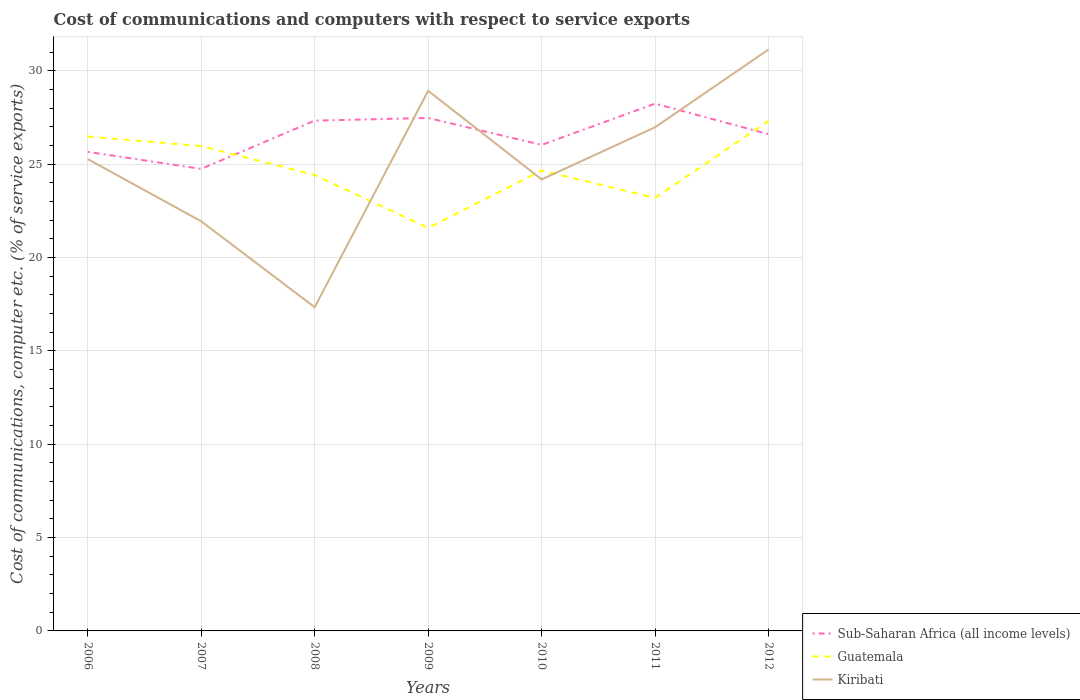Is the number of lines equal to the number of legend labels?
Ensure brevity in your answer.  Yes. Across all years, what is the maximum cost of communications and computers in Guatemala?
Make the answer very short. 21.59. In which year was the cost of communications and computers in Sub-Saharan Africa (all income levels) maximum?
Provide a short and direct response. 2007. What is the total cost of communications and computers in Kiribati in the graph?
Ensure brevity in your answer.  3.33. What is the difference between the highest and the second highest cost of communications and computers in Sub-Saharan Africa (all income levels)?
Offer a terse response. 3.49. How many lines are there?
Give a very brief answer. 3. What is the difference between two consecutive major ticks on the Y-axis?
Your answer should be very brief. 5. Are the values on the major ticks of Y-axis written in scientific E-notation?
Offer a terse response. No. Does the graph contain any zero values?
Your answer should be compact. No. Does the graph contain grids?
Your answer should be compact. Yes. What is the title of the graph?
Offer a terse response. Cost of communications and computers with respect to service exports. What is the label or title of the X-axis?
Offer a terse response. Years. What is the label or title of the Y-axis?
Your answer should be very brief. Cost of communications, computer etc. (% of service exports). What is the Cost of communications, computer etc. (% of service exports) of Sub-Saharan Africa (all income levels) in 2006?
Offer a very short reply. 25.66. What is the Cost of communications, computer etc. (% of service exports) of Guatemala in 2006?
Offer a very short reply. 26.49. What is the Cost of communications, computer etc. (% of service exports) of Kiribati in 2006?
Your response must be concise. 25.28. What is the Cost of communications, computer etc. (% of service exports) in Sub-Saharan Africa (all income levels) in 2007?
Your answer should be compact. 24.75. What is the Cost of communications, computer etc. (% of service exports) of Guatemala in 2007?
Ensure brevity in your answer.  25.98. What is the Cost of communications, computer etc. (% of service exports) of Kiribati in 2007?
Offer a terse response. 21.94. What is the Cost of communications, computer etc. (% of service exports) of Sub-Saharan Africa (all income levels) in 2008?
Provide a short and direct response. 27.34. What is the Cost of communications, computer etc. (% of service exports) of Guatemala in 2008?
Provide a succinct answer. 24.42. What is the Cost of communications, computer etc. (% of service exports) in Kiribati in 2008?
Provide a short and direct response. 17.34. What is the Cost of communications, computer etc. (% of service exports) in Sub-Saharan Africa (all income levels) in 2009?
Your response must be concise. 27.48. What is the Cost of communications, computer etc. (% of service exports) of Guatemala in 2009?
Your response must be concise. 21.59. What is the Cost of communications, computer etc. (% of service exports) of Kiribati in 2009?
Your response must be concise. 28.94. What is the Cost of communications, computer etc. (% of service exports) in Sub-Saharan Africa (all income levels) in 2010?
Provide a short and direct response. 26.04. What is the Cost of communications, computer etc. (% of service exports) in Guatemala in 2010?
Offer a very short reply. 24.66. What is the Cost of communications, computer etc. (% of service exports) in Kiribati in 2010?
Keep it short and to the point. 24.19. What is the Cost of communications, computer etc. (% of service exports) of Sub-Saharan Africa (all income levels) in 2011?
Offer a very short reply. 28.25. What is the Cost of communications, computer etc. (% of service exports) of Guatemala in 2011?
Keep it short and to the point. 23.2. What is the Cost of communications, computer etc. (% of service exports) of Kiribati in 2011?
Provide a succinct answer. 26.98. What is the Cost of communications, computer etc. (% of service exports) in Sub-Saharan Africa (all income levels) in 2012?
Make the answer very short. 26.61. What is the Cost of communications, computer etc. (% of service exports) of Guatemala in 2012?
Make the answer very short. 27.33. What is the Cost of communications, computer etc. (% of service exports) of Kiribati in 2012?
Your response must be concise. 31.15. Across all years, what is the maximum Cost of communications, computer etc. (% of service exports) of Sub-Saharan Africa (all income levels)?
Offer a terse response. 28.25. Across all years, what is the maximum Cost of communications, computer etc. (% of service exports) of Guatemala?
Offer a very short reply. 27.33. Across all years, what is the maximum Cost of communications, computer etc. (% of service exports) of Kiribati?
Your response must be concise. 31.15. Across all years, what is the minimum Cost of communications, computer etc. (% of service exports) in Sub-Saharan Africa (all income levels)?
Keep it short and to the point. 24.75. Across all years, what is the minimum Cost of communications, computer etc. (% of service exports) of Guatemala?
Your response must be concise. 21.59. Across all years, what is the minimum Cost of communications, computer etc. (% of service exports) in Kiribati?
Keep it short and to the point. 17.34. What is the total Cost of communications, computer etc. (% of service exports) in Sub-Saharan Africa (all income levels) in the graph?
Offer a very short reply. 186.14. What is the total Cost of communications, computer etc. (% of service exports) of Guatemala in the graph?
Provide a short and direct response. 173.67. What is the total Cost of communications, computer etc. (% of service exports) of Kiribati in the graph?
Make the answer very short. 175.83. What is the difference between the Cost of communications, computer etc. (% of service exports) in Sub-Saharan Africa (all income levels) in 2006 and that in 2007?
Your response must be concise. 0.91. What is the difference between the Cost of communications, computer etc. (% of service exports) of Guatemala in 2006 and that in 2007?
Your answer should be compact. 0.51. What is the difference between the Cost of communications, computer etc. (% of service exports) of Kiribati in 2006 and that in 2007?
Ensure brevity in your answer.  3.33. What is the difference between the Cost of communications, computer etc. (% of service exports) in Sub-Saharan Africa (all income levels) in 2006 and that in 2008?
Provide a succinct answer. -1.67. What is the difference between the Cost of communications, computer etc. (% of service exports) in Guatemala in 2006 and that in 2008?
Your response must be concise. 2.06. What is the difference between the Cost of communications, computer etc. (% of service exports) in Kiribati in 2006 and that in 2008?
Keep it short and to the point. 7.94. What is the difference between the Cost of communications, computer etc. (% of service exports) of Sub-Saharan Africa (all income levels) in 2006 and that in 2009?
Make the answer very short. -1.82. What is the difference between the Cost of communications, computer etc. (% of service exports) of Guatemala in 2006 and that in 2009?
Offer a terse response. 4.89. What is the difference between the Cost of communications, computer etc. (% of service exports) in Kiribati in 2006 and that in 2009?
Offer a terse response. -3.66. What is the difference between the Cost of communications, computer etc. (% of service exports) in Sub-Saharan Africa (all income levels) in 2006 and that in 2010?
Keep it short and to the point. -0.37. What is the difference between the Cost of communications, computer etc. (% of service exports) in Guatemala in 2006 and that in 2010?
Offer a very short reply. 1.82. What is the difference between the Cost of communications, computer etc. (% of service exports) of Kiribati in 2006 and that in 2010?
Your answer should be compact. 1.09. What is the difference between the Cost of communications, computer etc. (% of service exports) in Sub-Saharan Africa (all income levels) in 2006 and that in 2011?
Make the answer very short. -2.58. What is the difference between the Cost of communications, computer etc. (% of service exports) in Guatemala in 2006 and that in 2011?
Ensure brevity in your answer.  3.29. What is the difference between the Cost of communications, computer etc. (% of service exports) of Kiribati in 2006 and that in 2011?
Your answer should be compact. -1.71. What is the difference between the Cost of communications, computer etc. (% of service exports) in Sub-Saharan Africa (all income levels) in 2006 and that in 2012?
Your response must be concise. -0.95. What is the difference between the Cost of communications, computer etc. (% of service exports) of Guatemala in 2006 and that in 2012?
Ensure brevity in your answer.  -0.84. What is the difference between the Cost of communications, computer etc. (% of service exports) of Kiribati in 2006 and that in 2012?
Make the answer very short. -5.87. What is the difference between the Cost of communications, computer etc. (% of service exports) in Sub-Saharan Africa (all income levels) in 2007 and that in 2008?
Make the answer very short. -2.58. What is the difference between the Cost of communications, computer etc. (% of service exports) of Guatemala in 2007 and that in 2008?
Make the answer very short. 1.55. What is the difference between the Cost of communications, computer etc. (% of service exports) in Kiribati in 2007 and that in 2008?
Provide a short and direct response. 4.6. What is the difference between the Cost of communications, computer etc. (% of service exports) in Sub-Saharan Africa (all income levels) in 2007 and that in 2009?
Offer a terse response. -2.73. What is the difference between the Cost of communications, computer etc. (% of service exports) of Guatemala in 2007 and that in 2009?
Ensure brevity in your answer.  4.38. What is the difference between the Cost of communications, computer etc. (% of service exports) in Kiribati in 2007 and that in 2009?
Provide a short and direct response. -6.99. What is the difference between the Cost of communications, computer etc. (% of service exports) of Sub-Saharan Africa (all income levels) in 2007 and that in 2010?
Your answer should be compact. -1.28. What is the difference between the Cost of communications, computer etc. (% of service exports) of Guatemala in 2007 and that in 2010?
Your answer should be compact. 1.31. What is the difference between the Cost of communications, computer etc. (% of service exports) of Kiribati in 2007 and that in 2010?
Ensure brevity in your answer.  -2.25. What is the difference between the Cost of communications, computer etc. (% of service exports) of Sub-Saharan Africa (all income levels) in 2007 and that in 2011?
Ensure brevity in your answer.  -3.49. What is the difference between the Cost of communications, computer etc. (% of service exports) in Guatemala in 2007 and that in 2011?
Provide a succinct answer. 2.78. What is the difference between the Cost of communications, computer etc. (% of service exports) in Kiribati in 2007 and that in 2011?
Give a very brief answer. -5.04. What is the difference between the Cost of communications, computer etc. (% of service exports) of Sub-Saharan Africa (all income levels) in 2007 and that in 2012?
Offer a very short reply. -1.86. What is the difference between the Cost of communications, computer etc. (% of service exports) of Guatemala in 2007 and that in 2012?
Your answer should be compact. -1.35. What is the difference between the Cost of communications, computer etc. (% of service exports) of Kiribati in 2007 and that in 2012?
Make the answer very short. -9.21. What is the difference between the Cost of communications, computer etc. (% of service exports) of Sub-Saharan Africa (all income levels) in 2008 and that in 2009?
Keep it short and to the point. -0.14. What is the difference between the Cost of communications, computer etc. (% of service exports) in Guatemala in 2008 and that in 2009?
Your response must be concise. 2.83. What is the difference between the Cost of communications, computer etc. (% of service exports) of Kiribati in 2008 and that in 2009?
Provide a succinct answer. -11.59. What is the difference between the Cost of communications, computer etc. (% of service exports) of Sub-Saharan Africa (all income levels) in 2008 and that in 2010?
Make the answer very short. 1.3. What is the difference between the Cost of communications, computer etc. (% of service exports) of Guatemala in 2008 and that in 2010?
Provide a succinct answer. -0.24. What is the difference between the Cost of communications, computer etc. (% of service exports) of Kiribati in 2008 and that in 2010?
Ensure brevity in your answer.  -6.85. What is the difference between the Cost of communications, computer etc. (% of service exports) of Sub-Saharan Africa (all income levels) in 2008 and that in 2011?
Ensure brevity in your answer.  -0.91. What is the difference between the Cost of communications, computer etc. (% of service exports) in Guatemala in 2008 and that in 2011?
Your answer should be very brief. 1.22. What is the difference between the Cost of communications, computer etc. (% of service exports) in Kiribati in 2008 and that in 2011?
Offer a very short reply. -9.64. What is the difference between the Cost of communications, computer etc. (% of service exports) in Sub-Saharan Africa (all income levels) in 2008 and that in 2012?
Your answer should be compact. 0.73. What is the difference between the Cost of communications, computer etc. (% of service exports) in Guatemala in 2008 and that in 2012?
Ensure brevity in your answer.  -2.91. What is the difference between the Cost of communications, computer etc. (% of service exports) of Kiribati in 2008 and that in 2012?
Your response must be concise. -13.81. What is the difference between the Cost of communications, computer etc. (% of service exports) in Sub-Saharan Africa (all income levels) in 2009 and that in 2010?
Give a very brief answer. 1.44. What is the difference between the Cost of communications, computer etc. (% of service exports) in Guatemala in 2009 and that in 2010?
Keep it short and to the point. -3.07. What is the difference between the Cost of communications, computer etc. (% of service exports) of Kiribati in 2009 and that in 2010?
Ensure brevity in your answer.  4.75. What is the difference between the Cost of communications, computer etc. (% of service exports) in Sub-Saharan Africa (all income levels) in 2009 and that in 2011?
Give a very brief answer. -0.77. What is the difference between the Cost of communications, computer etc. (% of service exports) in Guatemala in 2009 and that in 2011?
Offer a very short reply. -1.61. What is the difference between the Cost of communications, computer etc. (% of service exports) of Kiribati in 2009 and that in 2011?
Offer a very short reply. 1.95. What is the difference between the Cost of communications, computer etc. (% of service exports) of Sub-Saharan Africa (all income levels) in 2009 and that in 2012?
Make the answer very short. 0.87. What is the difference between the Cost of communications, computer etc. (% of service exports) of Guatemala in 2009 and that in 2012?
Ensure brevity in your answer.  -5.74. What is the difference between the Cost of communications, computer etc. (% of service exports) in Kiribati in 2009 and that in 2012?
Your answer should be compact. -2.21. What is the difference between the Cost of communications, computer etc. (% of service exports) in Sub-Saharan Africa (all income levels) in 2010 and that in 2011?
Provide a succinct answer. -2.21. What is the difference between the Cost of communications, computer etc. (% of service exports) in Guatemala in 2010 and that in 2011?
Your response must be concise. 1.47. What is the difference between the Cost of communications, computer etc. (% of service exports) of Kiribati in 2010 and that in 2011?
Offer a terse response. -2.8. What is the difference between the Cost of communications, computer etc. (% of service exports) in Sub-Saharan Africa (all income levels) in 2010 and that in 2012?
Provide a short and direct response. -0.58. What is the difference between the Cost of communications, computer etc. (% of service exports) in Guatemala in 2010 and that in 2012?
Your answer should be compact. -2.67. What is the difference between the Cost of communications, computer etc. (% of service exports) in Kiribati in 2010 and that in 2012?
Your response must be concise. -6.96. What is the difference between the Cost of communications, computer etc. (% of service exports) of Sub-Saharan Africa (all income levels) in 2011 and that in 2012?
Provide a succinct answer. 1.63. What is the difference between the Cost of communications, computer etc. (% of service exports) of Guatemala in 2011 and that in 2012?
Provide a short and direct response. -4.13. What is the difference between the Cost of communications, computer etc. (% of service exports) in Kiribati in 2011 and that in 2012?
Ensure brevity in your answer.  -4.17. What is the difference between the Cost of communications, computer etc. (% of service exports) of Sub-Saharan Africa (all income levels) in 2006 and the Cost of communications, computer etc. (% of service exports) of Guatemala in 2007?
Provide a short and direct response. -0.31. What is the difference between the Cost of communications, computer etc. (% of service exports) of Sub-Saharan Africa (all income levels) in 2006 and the Cost of communications, computer etc. (% of service exports) of Kiribati in 2007?
Your answer should be compact. 3.72. What is the difference between the Cost of communications, computer etc. (% of service exports) in Guatemala in 2006 and the Cost of communications, computer etc. (% of service exports) in Kiribati in 2007?
Make the answer very short. 4.54. What is the difference between the Cost of communications, computer etc. (% of service exports) of Sub-Saharan Africa (all income levels) in 2006 and the Cost of communications, computer etc. (% of service exports) of Guatemala in 2008?
Provide a succinct answer. 1.24. What is the difference between the Cost of communications, computer etc. (% of service exports) in Sub-Saharan Africa (all income levels) in 2006 and the Cost of communications, computer etc. (% of service exports) in Kiribati in 2008?
Your response must be concise. 8.32. What is the difference between the Cost of communications, computer etc. (% of service exports) of Guatemala in 2006 and the Cost of communications, computer etc. (% of service exports) of Kiribati in 2008?
Your answer should be compact. 9.14. What is the difference between the Cost of communications, computer etc. (% of service exports) of Sub-Saharan Africa (all income levels) in 2006 and the Cost of communications, computer etc. (% of service exports) of Guatemala in 2009?
Provide a short and direct response. 4.07. What is the difference between the Cost of communications, computer etc. (% of service exports) in Sub-Saharan Africa (all income levels) in 2006 and the Cost of communications, computer etc. (% of service exports) in Kiribati in 2009?
Your answer should be compact. -3.27. What is the difference between the Cost of communications, computer etc. (% of service exports) of Guatemala in 2006 and the Cost of communications, computer etc. (% of service exports) of Kiribati in 2009?
Keep it short and to the point. -2.45. What is the difference between the Cost of communications, computer etc. (% of service exports) of Sub-Saharan Africa (all income levels) in 2006 and the Cost of communications, computer etc. (% of service exports) of Kiribati in 2010?
Make the answer very short. 1.48. What is the difference between the Cost of communications, computer etc. (% of service exports) of Guatemala in 2006 and the Cost of communications, computer etc. (% of service exports) of Kiribati in 2010?
Keep it short and to the point. 2.3. What is the difference between the Cost of communications, computer etc. (% of service exports) of Sub-Saharan Africa (all income levels) in 2006 and the Cost of communications, computer etc. (% of service exports) of Guatemala in 2011?
Offer a very short reply. 2.47. What is the difference between the Cost of communications, computer etc. (% of service exports) of Sub-Saharan Africa (all income levels) in 2006 and the Cost of communications, computer etc. (% of service exports) of Kiribati in 2011?
Give a very brief answer. -1.32. What is the difference between the Cost of communications, computer etc. (% of service exports) in Guatemala in 2006 and the Cost of communications, computer etc. (% of service exports) in Kiribati in 2011?
Your answer should be compact. -0.5. What is the difference between the Cost of communications, computer etc. (% of service exports) in Sub-Saharan Africa (all income levels) in 2006 and the Cost of communications, computer etc. (% of service exports) in Guatemala in 2012?
Ensure brevity in your answer.  -1.66. What is the difference between the Cost of communications, computer etc. (% of service exports) of Sub-Saharan Africa (all income levels) in 2006 and the Cost of communications, computer etc. (% of service exports) of Kiribati in 2012?
Your answer should be very brief. -5.49. What is the difference between the Cost of communications, computer etc. (% of service exports) in Guatemala in 2006 and the Cost of communications, computer etc. (% of service exports) in Kiribati in 2012?
Give a very brief answer. -4.66. What is the difference between the Cost of communications, computer etc. (% of service exports) in Sub-Saharan Africa (all income levels) in 2007 and the Cost of communications, computer etc. (% of service exports) in Guatemala in 2008?
Your answer should be compact. 0.33. What is the difference between the Cost of communications, computer etc. (% of service exports) of Sub-Saharan Africa (all income levels) in 2007 and the Cost of communications, computer etc. (% of service exports) of Kiribati in 2008?
Your answer should be very brief. 7.41. What is the difference between the Cost of communications, computer etc. (% of service exports) in Guatemala in 2007 and the Cost of communications, computer etc. (% of service exports) in Kiribati in 2008?
Provide a succinct answer. 8.63. What is the difference between the Cost of communications, computer etc. (% of service exports) in Sub-Saharan Africa (all income levels) in 2007 and the Cost of communications, computer etc. (% of service exports) in Guatemala in 2009?
Offer a very short reply. 3.16. What is the difference between the Cost of communications, computer etc. (% of service exports) of Sub-Saharan Africa (all income levels) in 2007 and the Cost of communications, computer etc. (% of service exports) of Kiribati in 2009?
Provide a succinct answer. -4.18. What is the difference between the Cost of communications, computer etc. (% of service exports) of Guatemala in 2007 and the Cost of communications, computer etc. (% of service exports) of Kiribati in 2009?
Offer a very short reply. -2.96. What is the difference between the Cost of communications, computer etc. (% of service exports) of Sub-Saharan Africa (all income levels) in 2007 and the Cost of communications, computer etc. (% of service exports) of Guatemala in 2010?
Keep it short and to the point. 0.09. What is the difference between the Cost of communications, computer etc. (% of service exports) in Sub-Saharan Africa (all income levels) in 2007 and the Cost of communications, computer etc. (% of service exports) in Kiribati in 2010?
Your answer should be very brief. 0.57. What is the difference between the Cost of communications, computer etc. (% of service exports) of Guatemala in 2007 and the Cost of communications, computer etc. (% of service exports) of Kiribati in 2010?
Provide a short and direct response. 1.79. What is the difference between the Cost of communications, computer etc. (% of service exports) in Sub-Saharan Africa (all income levels) in 2007 and the Cost of communications, computer etc. (% of service exports) in Guatemala in 2011?
Keep it short and to the point. 1.56. What is the difference between the Cost of communications, computer etc. (% of service exports) in Sub-Saharan Africa (all income levels) in 2007 and the Cost of communications, computer etc. (% of service exports) in Kiribati in 2011?
Your answer should be very brief. -2.23. What is the difference between the Cost of communications, computer etc. (% of service exports) of Guatemala in 2007 and the Cost of communications, computer etc. (% of service exports) of Kiribati in 2011?
Give a very brief answer. -1.01. What is the difference between the Cost of communications, computer etc. (% of service exports) of Sub-Saharan Africa (all income levels) in 2007 and the Cost of communications, computer etc. (% of service exports) of Guatemala in 2012?
Provide a succinct answer. -2.57. What is the difference between the Cost of communications, computer etc. (% of service exports) of Sub-Saharan Africa (all income levels) in 2007 and the Cost of communications, computer etc. (% of service exports) of Kiribati in 2012?
Give a very brief answer. -6.4. What is the difference between the Cost of communications, computer etc. (% of service exports) of Guatemala in 2007 and the Cost of communications, computer etc. (% of service exports) of Kiribati in 2012?
Offer a terse response. -5.17. What is the difference between the Cost of communications, computer etc. (% of service exports) of Sub-Saharan Africa (all income levels) in 2008 and the Cost of communications, computer etc. (% of service exports) of Guatemala in 2009?
Make the answer very short. 5.75. What is the difference between the Cost of communications, computer etc. (% of service exports) in Sub-Saharan Africa (all income levels) in 2008 and the Cost of communications, computer etc. (% of service exports) in Kiribati in 2009?
Offer a terse response. -1.6. What is the difference between the Cost of communications, computer etc. (% of service exports) in Guatemala in 2008 and the Cost of communications, computer etc. (% of service exports) in Kiribati in 2009?
Keep it short and to the point. -4.51. What is the difference between the Cost of communications, computer etc. (% of service exports) of Sub-Saharan Africa (all income levels) in 2008 and the Cost of communications, computer etc. (% of service exports) of Guatemala in 2010?
Your answer should be very brief. 2.68. What is the difference between the Cost of communications, computer etc. (% of service exports) in Sub-Saharan Africa (all income levels) in 2008 and the Cost of communications, computer etc. (% of service exports) in Kiribati in 2010?
Your response must be concise. 3.15. What is the difference between the Cost of communications, computer etc. (% of service exports) of Guatemala in 2008 and the Cost of communications, computer etc. (% of service exports) of Kiribati in 2010?
Your response must be concise. 0.23. What is the difference between the Cost of communications, computer etc. (% of service exports) of Sub-Saharan Africa (all income levels) in 2008 and the Cost of communications, computer etc. (% of service exports) of Guatemala in 2011?
Your answer should be very brief. 4.14. What is the difference between the Cost of communications, computer etc. (% of service exports) of Sub-Saharan Africa (all income levels) in 2008 and the Cost of communications, computer etc. (% of service exports) of Kiribati in 2011?
Give a very brief answer. 0.35. What is the difference between the Cost of communications, computer etc. (% of service exports) in Guatemala in 2008 and the Cost of communications, computer etc. (% of service exports) in Kiribati in 2011?
Ensure brevity in your answer.  -2.56. What is the difference between the Cost of communications, computer etc. (% of service exports) in Sub-Saharan Africa (all income levels) in 2008 and the Cost of communications, computer etc. (% of service exports) in Guatemala in 2012?
Give a very brief answer. 0.01. What is the difference between the Cost of communications, computer etc. (% of service exports) of Sub-Saharan Africa (all income levels) in 2008 and the Cost of communications, computer etc. (% of service exports) of Kiribati in 2012?
Offer a terse response. -3.81. What is the difference between the Cost of communications, computer etc. (% of service exports) in Guatemala in 2008 and the Cost of communications, computer etc. (% of service exports) in Kiribati in 2012?
Offer a terse response. -6.73. What is the difference between the Cost of communications, computer etc. (% of service exports) in Sub-Saharan Africa (all income levels) in 2009 and the Cost of communications, computer etc. (% of service exports) in Guatemala in 2010?
Ensure brevity in your answer.  2.82. What is the difference between the Cost of communications, computer etc. (% of service exports) of Sub-Saharan Africa (all income levels) in 2009 and the Cost of communications, computer etc. (% of service exports) of Kiribati in 2010?
Your response must be concise. 3.29. What is the difference between the Cost of communications, computer etc. (% of service exports) of Guatemala in 2009 and the Cost of communications, computer etc. (% of service exports) of Kiribati in 2010?
Offer a very short reply. -2.6. What is the difference between the Cost of communications, computer etc. (% of service exports) of Sub-Saharan Africa (all income levels) in 2009 and the Cost of communications, computer etc. (% of service exports) of Guatemala in 2011?
Ensure brevity in your answer.  4.28. What is the difference between the Cost of communications, computer etc. (% of service exports) in Sub-Saharan Africa (all income levels) in 2009 and the Cost of communications, computer etc. (% of service exports) in Kiribati in 2011?
Give a very brief answer. 0.5. What is the difference between the Cost of communications, computer etc. (% of service exports) in Guatemala in 2009 and the Cost of communications, computer etc. (% of service exports) in Kiribati in 2011?
Your answer should be compact. -5.39. What is the difference between the Cost of communications, computer etc. (% of service exports) in Sub-Saharan Africa (all income levels) in 2009 and the Cost of communications, computer etc. (% of service exports) in Guatemala in 2012?
Give a very brief answer. 0.15. What is the difference between the Cost of communications, computer etc. (% of service exports) in Sub-Saharan Africa (all income levels) in 2009 and the Cost of communications, computer etc. (% of service exports) in Kiribati in 2012?
Offer a terse response. -3.67. What is the difference between the Cost of communications, computer etc. (% of service exports) of Guatemala in 2009 and the Cost of communications, computer etc. (% of service exports) of Kiribati in 2012?
Offer a terse response. -9.56. What is the difference between the Cost of communications, computer etc. (% of service exports) in Sub-Saharan Africa (all income levels) in 2010 and the Cost of communications, computer etc. (% of service exports) in Guatemala in 2011?
Ensure brevity in your answer.  2.84. What is the difference between the Cost of communications, computer etc. (% of service exports) of Sub-Saharan Africa (all income levels) in 2010 and the Cost of communications, computer etc. (% of service exports) of Kiribati in 2011?
Make the answer very short. -0.95. What is the difference between the Cost of communications, computer etc. (% of service exports) in Guatemala in 2010 and the Cost of communications, computer etc. (% of service exports) in Kiribati in 2011?
Your answer should be compact. -2.32. What is the difference between the Cost of communications, computer etc. (% of service exports) of Sub-Saharan Africa (all income levels) in 2010 and the Cost of communications, computer etc. (% of service exports) of Guatemala in 2012?
Offer a terse response. -1.29. What is the difference between the Cost of communications, computer etc. (% of service exports) in Sub-Saharan Africa (all income levels) in 2010 and the Cost of communications, computer etc. (% of service exports) in Kiribati in 2012?
Ensure brevity in your answer.  -5.11. What is the difference between the Cost of communications, computer etc. (% of service exports) in Guatemala in 2010 and the Cost of communications, computer etc. (% of service exports) in Kiribati in 2012?
Ensure brevity in your answer.  -6.49. What is the difference between the Cost of communications, computer etc. (% of service exports) of Sub-Saharan Africa (all income levels) in 2011 and the Cost of communications, computer etc. (% of service exports) of Guatemala in 2012?
Provide a short and direct response. 0.92. What is the difference between the Cost of communications, computer etc. (% of service exports) of Sub-Saharan Africa (all income levels) in 2011 and the Cost of communications, computer etc. (% of service exports) of Kiribati in 2012?
Provide a short and direct response. -2.9. What is the difference between the Cost of communications, computer etc. (% of service exports) of Guatemala in 2011 and the Cost of communications, computer etc. (% of service exports) of Kiribati in 2012?
Your response must be concise. -7.95. What is the average Cost of communications, computer etc. (% of service exports) of Sub-Saharan Africa (all income levels) per year?
Keep it short and to the point. 26.59. What is the average Cost of communications, computer etc. (% of service exports) of Guatemala per year?
Ensure brevity in your answer.  24.81. What is the average Cost of communications, computer etc. (% of service exports) in Kiribati per year?
Ensure brevity in your answer.  25.12. In the year 2006, what is the difference between the Cost of communications, computer etc. (% of service exports) of Sub-Saharan Africa (all income levels) and Cost of communications, computer etc. (% of service exports) of Guatemala?
Give a very brief answer. -0.82. In the year 2006, what is the difference between the Cost of communications, computer etc. (% of service exports) in Sub-Saharan Africa (all income levels) and Cost of communications, computer etc. (% of service exports) in Kiribati?
Give a very brief answer. 0.39. In the year 2006, what is the difference between the Cost of communications, computer etc. (% of service exports) of Guatemala and Cost of communications, computer etc. (% of service exports) of Kiribati?
Keep it short and to the point. 1.21. In the year 2007, what is the difference between the Cost of communications, computer etc. (% of service exports) of Sub-Saharan Africa (all income levels) and Cost of communications, computer etc. (% of service exports) of Guatemala?
Your response must be concise. -1.22. In the year 2007, what is the difference between the Cost of communications, computer etc. (% of service exports) in Sub-Saharan Africa (all income levels) and Cost of communications, computer etc. (% of service exports) in Kiribati?
Your answer should be compact. 2.81. In the year 2007, what is the difference between the Cost of communications, computer etc. (% of service exports) in Guatemala and Cost of communications, computer etc. (% of service exports) in Kiribati?
Your response must be concise. 4.03. In the year 2008, what is the difference between the Cost of communications, computer etc. (% of service exports) of Sub-Saharan Africa (all income levels) and Cost of communications, computer etc. (% of service exports) of Guatemala?
Your answer should be compact. 2.92. In the year 2008, what is the difference between the Cost of communications, computer etc. (% of service exports) in Sub-Saharan Africa (all income levels) and Cost of communications, computer etc. (% of service exports) in Kiribati?
Your answer should be very brief. 10. In the year 2008, what is the difference between the Cost of communications, computer etc. (% of service exports) in Guatemala and Cost of communications, computer etc. (% of service exports) in Kiribati?
Your answer should be compact. 7.08. In the year 2009, what is the difference between the Cost of communications, computer etc. (% of service exports) in Sub-Saharan Africa (all income levels) and Cost of communications, computer etc. (% of service exports) in Guatemala?
Give a very brief answer. 5.89. In the year 2009, what is the difference between the Cost of communications, computer etc. (% of service exports) of Sub-Saharan Africa (all income levels) and Cost of communications, computer etc. (% of service exports) of Kiribati?
Your answer should be very brief. -1.46. In the year 2009, what is the difference between the Cost of communications, computer etc. (% of service exports) in Guatemala and Cost of communications, computer etc. (% of service exports) in Kiribati?
Your response must be concise. -7.35. In the year 2010, what is the difference between the Cost of communications, computer etc. (% of service exports) of Sub-Saharan Africa (all income levels) and Cost of communications, computer etc. (% of service exports) of Guatemala?
Make the answer very short. 1.37. In the year 2010, what is the difference between the Cost of communications, computer etc. (% of service exports) of Sub-Saharan Africa (all income levels) and Cost of communications, computer etc. (% of service exports) of Kiribati?
Your answer should be compact. 1.85. In the year 2010, what is the difference between the Cost of communications, computer etc. (% of service exports) of Guatemala and Cost of communications, computer etc. (% of service exports) of Kiribati?
Ensure brevity in your answer.  0.47. In the year 2011, what is the difference between the Cost of communications, computer etc. (% of service exports) in Sub-Saharan Africa (all income levels) and Cost of communications, computer etc. (% of service exports) in Guatemala?
Your response must be concise. 5.05. In the year 2011, what is the difference between the Cost of communications, computer etc. (% of service exports) of Sub-Saharan Africa (all income levels) and Cost of communications, computer etc. (% of service exports) of Kiribati?
Ensure brevity in your answer.  1.26. In the year 2011, what is the difference between the Cost of communications, computer etc. (% of service exports) of Guatemala and Cost of communications, computer etc. (% of service exports) of Kiribati?
Provide a succinct answer. -3.79. In the year 2012, what is the difference between the Cost of communications, computer etc. (% of service exports) of Sub-Saharan Africa (all income levels) and Cost of communications, computer etc. (% of service exports) of Guatemala?
Provide a short and direct response. -0.72. In the year 2012, what is the difference between the Cost of communications, computer etc. (% of service exports) in Sub-Saharan Africa (all income levels) and Cost of communications, computer etc. (% of service exports) in Kiribati?
Offer a very short reply. -4.54. In the year 2012, what is the difference between the Cost of communications, computer etc. (% of service exports) of Guatemala and Cost of communications, computer etc. (% of service exports) of Kiribati?
Provide a short and direct response. -3.82. What is the ratio of the Cost of communications, computer etc. (% of service exports) of Sub-Saharan Africa (all income levels) in 2006 to that in 2007?
Your answer should be very brief. 1.04. What is the ratio of the Cost of communications, computer etc. (% of service exports) in Guatemala in 2006 to that in 2007?
Your answer should be compact. 1.02. What is the ratio of the Cost of communications, computer etc. (% of service exports) in Kiribati in 2006 to that in 2007?
Keep it short and to the point. 1.15. What is the ratio of the Cost of communications, computer etc. (% of service exports) in Sub-Saharan Africa (all income levels) in 2006 to that in 2008?
Your answer should be very brief. 0.94. What is the ratio of the Cost of communications, computer etc. (% of service exports) in Guatemala in 2006 to that in 2008?
Your answer should be compact. 1.08. What is the ratio of the Cost of communications, computer etc. (% of service exports) in Kiribati in 2006 to that in 2008?
Offer a terse response. 1.46. What is the ratio of the Cost of communications, computer etc. (% of service exports) in Sub-Saharan Africa (all income levels) in 2006 to that in 2009?
Your answer should be very brief. 0.93. What is the ratio of the Cost of communications, computer etc. (% of service exports) in Guatemala in 2006 to that in 2009?
Give a very brief answer. 1.23. What is the ratio of the Cost of communications, computer etc. (% of service exports) in Kiribati in 2006 to that in 2009?
Offer a terse response. 0.87. What is the ratio of the Cost of communications, computer etc. (% of service exports) of Sub-Saharan Africa (all income levels) in 2006 to that in 2010?
Your answer should be compact. 0.99. What is the ratio of the Cost of communications, computer etc. (% of service exports) in Guatemala in 2006 to that in 2010?
Your answer should be compact. 1.07. What is the ratio of the Cost of communications, computer etc. (% of service exports) in Kiribati in 2006 to that in 2010?
Keep it short and to the point. 1.05. What is the ratio of the Cost of communications, computer etc. (% of service exports) in Sub-Saharan Africa (all income levels) in 2006 to that in 2011?
Give a very brief answer. 0.91. What is the ratio of the Cost of communications, computer etc. (% of service exports) in Guatemala in 2006 to that in 2011?
Your answer should be compact. 1.14. What is the ratio of the Cost of communications, computer etc. (% of service exports) in Kiribati in 2006 to that in 2011?
Provide a short and direct response. 0.94. What is the ratio of the Cost of communications, computer etc. (% of service exports) in Sub-Saharan Africa (all income levels) in 2006 to that in 2012?
Keep it short and to the point. 0.96. What is the ratio of the Cost of communications, computer etc. (% of service exports) of Guatemala in 2006 to that in 2012?
Offer a terse response. 0.97. What is the ratio of the Cost of communications, computer etc. (% of service exports) in Kiribati in 2006 to that in 2012?
Offer a very short reply. 0.81. What is the ratio of the Cost of communications, computer etc. (% of service exports) of Sub-Saharan Africa (all income levels) in 2007 to that in 2008?
Offer a terse response. 0.91. What is the ratio of the Cost of communications, computer etc. (% of service exports) in Guatemala in 2007 to that in 2008?
Provide a succinct answer. 1.06. What is the ratio of the Cost of communications, computer etc. (% of service exports) of Kiribati in 2007 to that in 2008?
Give a very brief answer. 1.27. What is the ratio of the Cost of communications, computer etc. (% of service exports) of Sub-Saharan Africa (all income levels) in 2007 to that in 2009?
Offer a very short reply. 0.9. What is the ratio of the Cost of communications, computer etc. (% of service exports) in Guatemala in 2007 to that in 2009?
Provide a short and direct response. 1.2. What is the ratio of the Cost of communications, computer etc. (% of service exports) in Kiribati in 2007 to that in 2009?
Provide a short and direct response. 0.76. What is the ratio of the Cost of communications, computer etc. (% of service exports) of Sub-Saharan Africa (all income levels) in 2007 to that in 2010?
Make the answer very short. 0.95. What is the ratio of the Cost of communications, computer etc. (% of service exports) of Guatemala in 2007 to that in 2010?
Your answer should be very brief. 1.05. What is the ratio of the Cost of communications, computer etc. (% of service exports) in Kiribati in 2007 to that in 2010?
Give a very brief answer. 0.91. What is the ratio of the Cost of communications, computer etc. (% of service exports) in Sub-Saharan Africa (all income levels) in 2007 to that in 2011?
Provide a succinct answer. 0.88. What is the ratio of the Cost of communications, computer etc. (% of service exports) in Guatemala in 2007 to that in 2011?
Provide a succinct answer. 1.12. What is the ratio of the Cost of communications, computer etc. (% of service exports) of Kiribati in 2007 to that in 2011?
Make the answer very short. 0.81. What is the ratio of the Cost of communications, computer etc. (% of service exports) in Sub-Saharan Africa (all income levels) in 2007 to that in 2012?
Offer a very short reply. 0.93. What is the ratio of the Cost of communications, computer etc. (% of service exports) of Guatemala in 2007 to that in 2012?
Offer a terse response. 0.95. What is the ratio of the Cost of communications, computer etc. (% of service exports) of Kiribati in 2007 to that in 2012?
Provide a short and direct response. 0.7. What is the ratio of the Cost of communications, computer etc. (% of service exports) of Sub-Saharan Africa (all income levels) in 2008 to that in 2009?
Your answer should be very brief. 0.99. What is the ratio of the Cost of communications, computer etc. (% of service exports) of Guatemala in 2008 to that in 2009?
Make the answer very short. 1.13. What is the ratio of the Cost of communications, computer etc. (% of service exports) of Kiribati in 2008 to that in 2009?
Offer a very short reply. 0.6. What is the ratio of the Cost of communications, computer etc. (% of service exports) in Sub-Saharan Africa (all income levels) in 2008 to that in 2010?
Make the answer very short. 1.05. What is the ratio of the Cost of communications, computer etc. (% of service exports) of Guatemala in 2008 to that in 2010?
Make the answer very short. 0.99. What is the ratio of the Cost of communications, computer etc. (% of service exports) of Kiribati in 2008 to that in 2010?
Give a very brief answer. 0.72. What is the ratio of the Cost of communications, computer etc. (% of service exports) of Sub-Saharan Africa (all income levels) in 2008 to that in 2011?
Your answer should be compact. 0.97. What is the ratio of the Cost of communications, computer etc. (% of service exports) in Guatemala in 2008 to that in 2011?
Ensure brevity in your answer.  1.05. What is the ratio of the Cost of communications, computer etc. (% of service exports) of Kiribati in 2008 to that in 2011?
Your answer should be very brief. 0.64. What is the ratio of the Cost of communications, computer etc. (% of service exports) of Sub-Saharan Africa (all income levels) in 2008 to that in 2012?
Your answer should be compact. 1.03. What is the ratio of the Cost of communications, computer etc. (% of service exports) in Guatemala in 2008 to that in 2012?
Your answer should be very brief. 0.89. What is the ratio of the Cost of communications, computer etc. (% of service exports) of Kiribati in 2008 to that in 2012?
Give a very brief answer. 0.56. What is the ratio of the Cost of communications, computer etc. (% of service exports) of Sub-Saharan Africa (all income levels) in 2009 to that in 2010?
Provide a succinct answer. 1.06. What is the ratio of the Cost of communications, computer etc. (% of service exports) in Guatemala in 2009 to that in 2010?
Offer a terse response. 0.88. What is the ratio of the Cost of communications, computer etc. (% of service exports) of Kiribati in 2009 to that in 2010?
Provide a short and direct response. 1.2. What is the ratio of the Cost of communications, computer etc. (% of service exports) of Sub-Saharan Africa (all income levels) in 2009 to that in 2011?
Your answer should be very brief. 0.97. What is the ratio of the Cost of communications, computer etc. (% of service exports) of Guatemala in 2009 to that in 2011?
Make the answer very short. 0.93. What is the ratio of the Cost of communications, computer etc. (% of service exports) of Kiribati in 2009 to that in 2011?
Give a very brief answer. 1.07. What is the ratio of the Cost of communications, computer etc. (% of service exports) in Sub-Saharan Africa (all income levels) in 2009 to that in 2012?
Keep it short and to the point. 1.03. What is the ratio of the Cost of communications, computer etc. (% of service exports) of Guatemala in 2009 to that in 2012?
Offer a terse response. 0.79. What is the ratio of the Cost of communications, computer etc. (% of service exports) of Kiribati in 2009 to that in 2012?
Offer a very short reply. 0.93. What is the ratio of the Cost of communications, computer etc. (% of service exports) of Sub-Saharan Africa (all income levels) in 2010 to that in 2011?
Offer a terse response. 0.92. What is the ratio of the Cost of communications, computer etc. (% of service exports) of Guatemala in 2010 to that in 2011?
Provide a succinct answer. 1.06. What is the ratio of the Cost of communications, computer etc. (% of service exports) in Kiribati in 2010 to that in 2011?
Ensure brevity in your answer.  0.9. What is the ratio of the Cost of communications, computer etc. (% of service exports) of Sub-Saharan Africa (all income levels) in 2010 to that in 2012?
Your response must be concise. 0.98. What is the ratio of the Cost of communications, computer etc. (% of service exports) of Guatemala in 2010 to that in 2012?
Your answer should be very brief. 0.9. What is the ratio of the Cost of communications, computer etc. (% of service exports) of Kiribati in 2010 to that in 2012?
Offer a terse response. 0.78. What is the ratio of the Cost of communications, computer etc. (% of service exports) in Sub-Saharan Africa (all income levels) in 2011 to that in 2012?
Provide a succinct answer. 1.06. What is the ratio of the Cost of communications, computer etc. (% of service exports) in Guatemala in 2011 to that in 2012?
Offer a very short reply. 0.85. What is the ratio of the Cost of communications, computer etc. (% of service exports) of Kiribati in 2011 to that in 2012?
Offer a terse response. 0.87. What is the difference between the highest and the second highest Cost of communications, computer etc. (% of service exports) of Sub-Saharan Africa (all income levels)?
Keep it short and to the point. 0.77. What is the difference between the highest and the second highest Cost of communications, computer etc. (% of service exports) of Guatemala?
Provide a short and direct response. 0.84. What is the difference between the highest and the second highest Cost of communications, computer etc. (% of service exports) of Kiribati?
Offer a terse response. 2.21. What is the difference between the highest and the lowest Cost of communications, computer etc. (% of service exports) of Sub-Saharan Africa (all income levels)?
Your response must be concise. 3.49. What is the difference between the highest and the lowest Cost of communications, computer etc. (% of service exports) in Guatemala?
Your answer should be compact. 5.74. What is the difference between the highest and the lowest Cost of communications, computer etc. (% of service exports) of Kiribati?
Give a very brief answer. 13.81. 